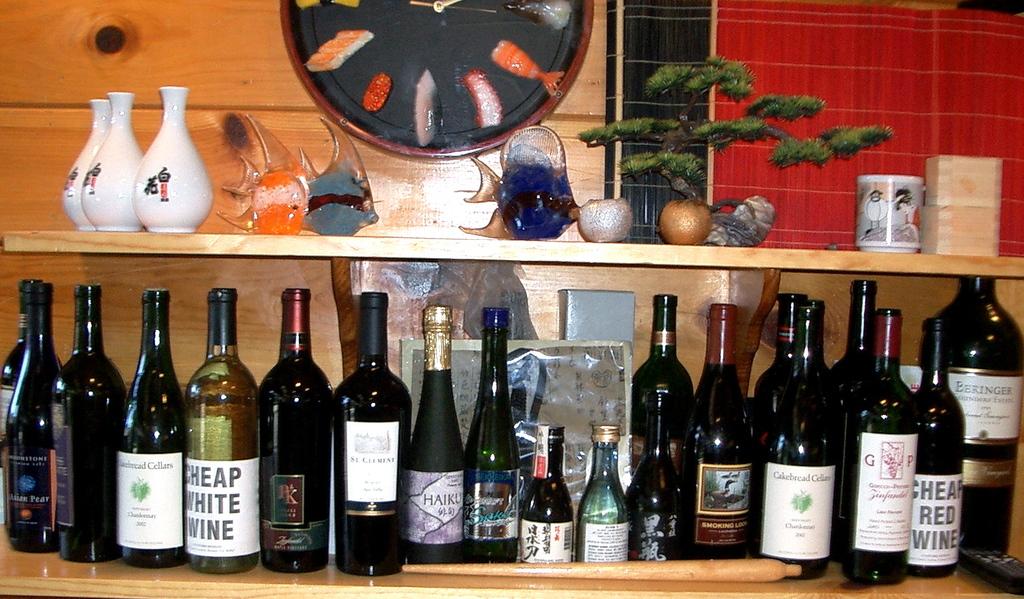Are there any red wine in the set ?
Your answer should be very brief. Yes. What is the name of the white wine?
Offer a terse response. Cheap white wine. 